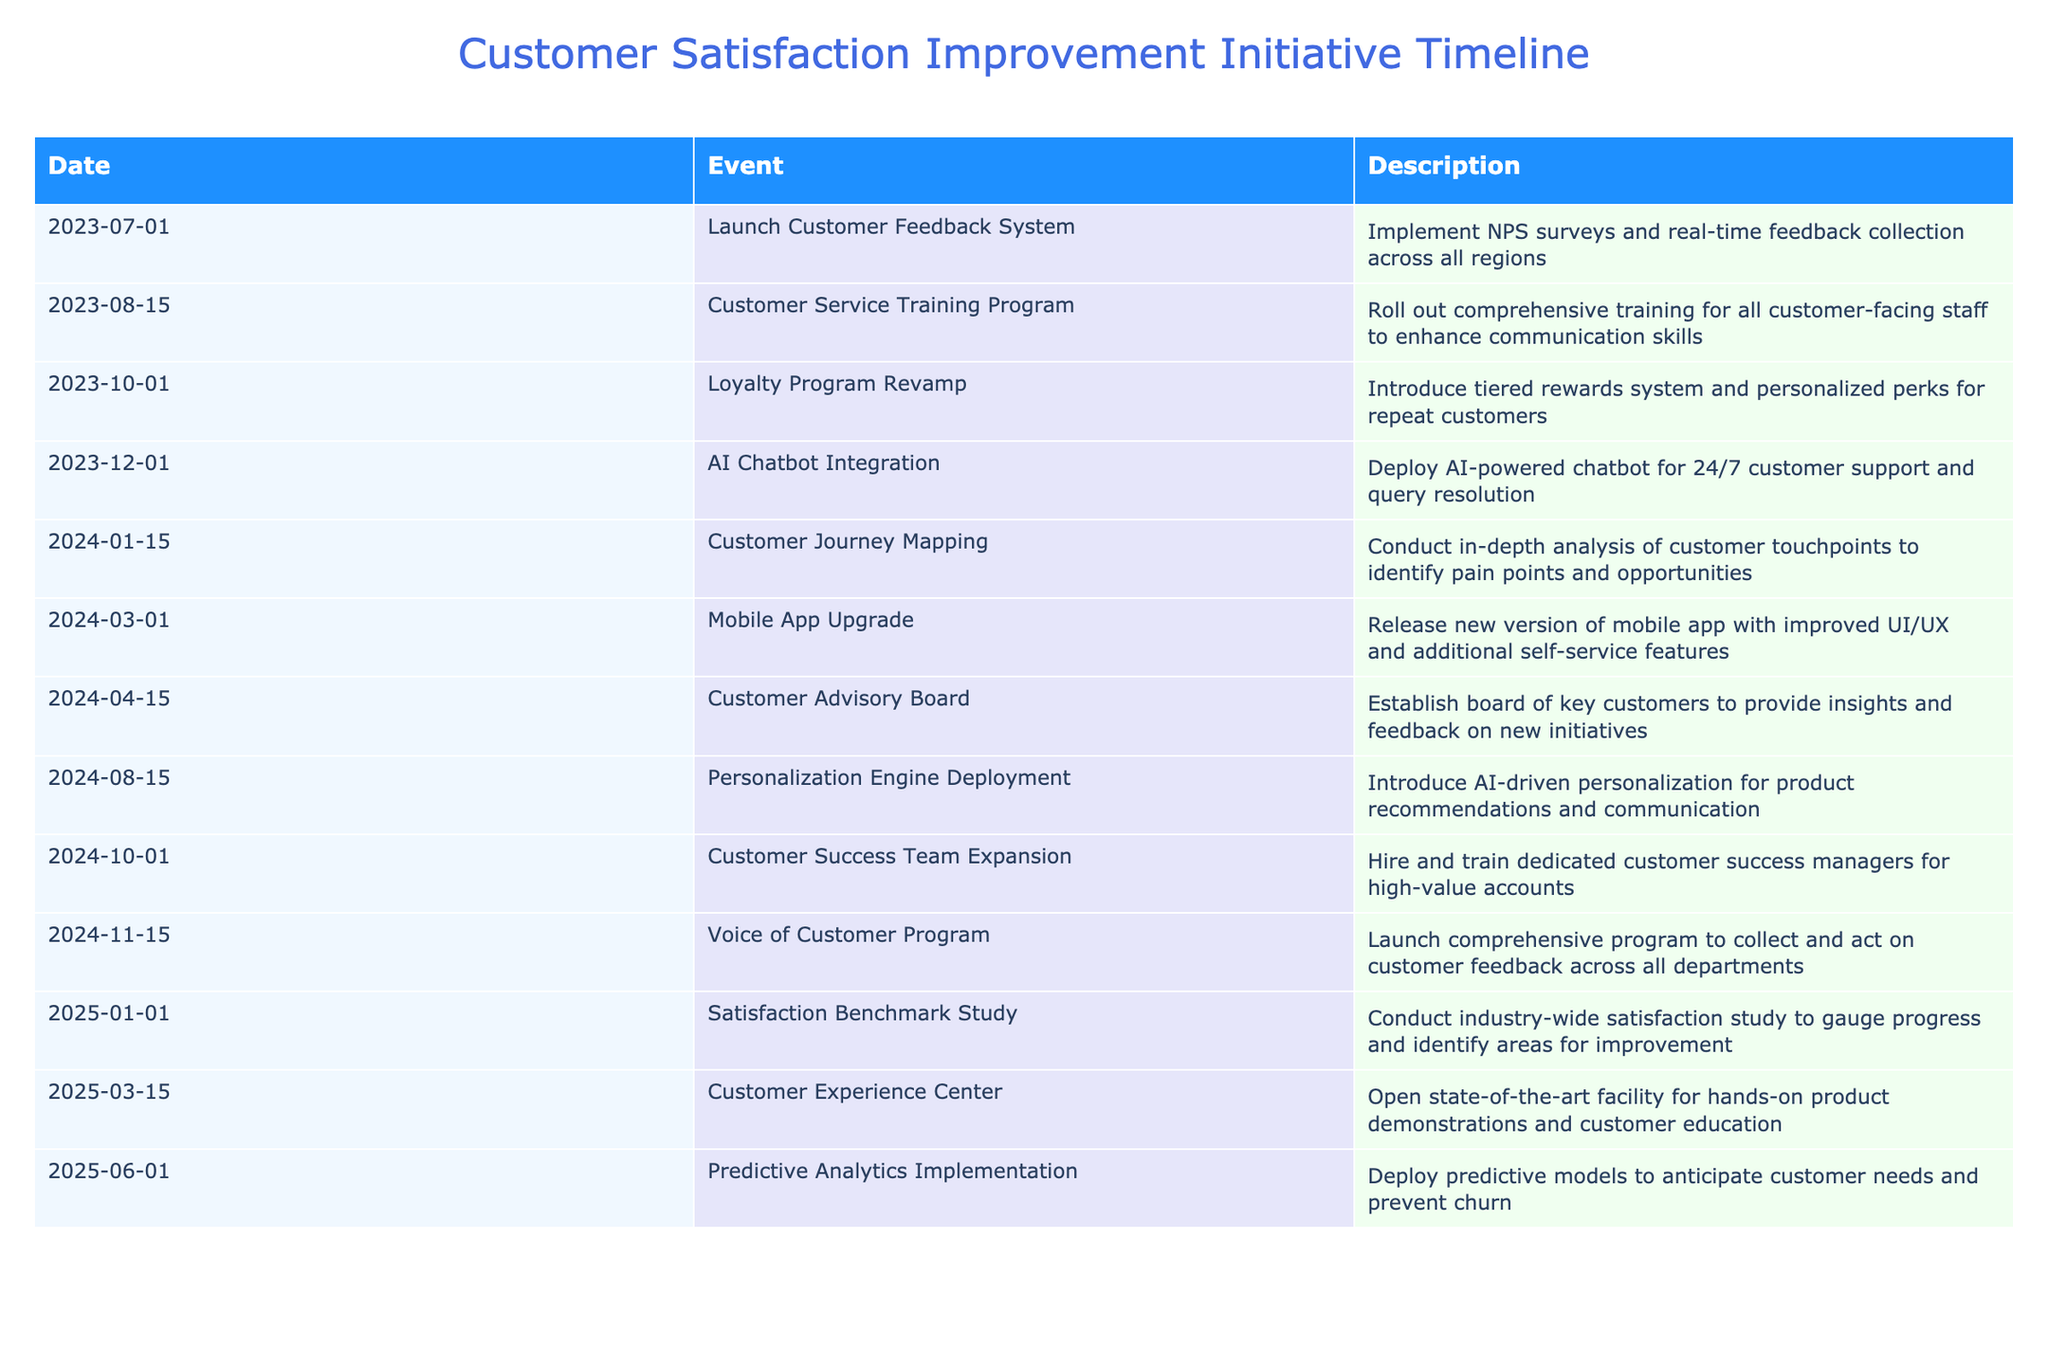What event is scheduled on December 1, 2023? The table shows that the event scheduled for December 1, 2023, is the "AI Chatbot Integration," which involves deploying an AI-powered chatbot for 24/7 customer support and query resolution.
Answer: AI Chatbot Integration How many events take place in 2024? By counting the events listed for the year 2024 in the table, there are eight events: Customer Journey Mapping, Mobile App Upgrade, Customer Advisory Board, Personalization Engine Deployment, Customer Success Team Expansion, Voice of Customer Program, Satisfaction Benchmark Study, and Customer Experience Center.
Answer: 8 Is there an event related to customer training before the end of 2023? The "Customer Service Training Program" is scheduled for August 15, 2023, which is before the end of the year. Hence, there is indeed an event related to customer training before 2023 concludes.
Answer: Yes What is the time gap between the "Loyalty Program Revamp" and "AI Chatbot Integration"? The "Loyalty Program Revamp" occurs on October 1, 2023, and the "AI Chatbot Integration" takes place on December 1, 2023. This results in a time gap of two months between these two events.
Answer: 2 months Which event marks the beginning of 2025? The table indicates that the first event of 2025 is the "Satisfaction Benchmark Study" scheduled for January 1, 2025, making it the starting event for that year.
Answer: Satisfaction Benchmark Study What is the total number of customer-focused initiatives planned for the next two years? By summing all the events listed for both 2024 (12 events) and 2025 (10 events) from the table, we find that a total of 12+3= 15 customer-focused initiatives are planned for the next two years.
Answer: 15 What was the event held the earliest in the timeline? Reviewing the dates in the table, the earliest event is the "Launch Customer Feedback System," which occurred on July 1, 2023.
Answer: Launch Customer Feedback System Which event occurs after the "Mobile App Upgrade" and before "Customer Success Team Expansion"? According to the table, the event that occurs after the "Mobile App Upgrade" on March 1, 2024, and before the "Customer Success Team Expansion" on October 1, 2024, is the "Customer Advisory Board" on April 15, 2024.
Answer: Customer Advisory Board 